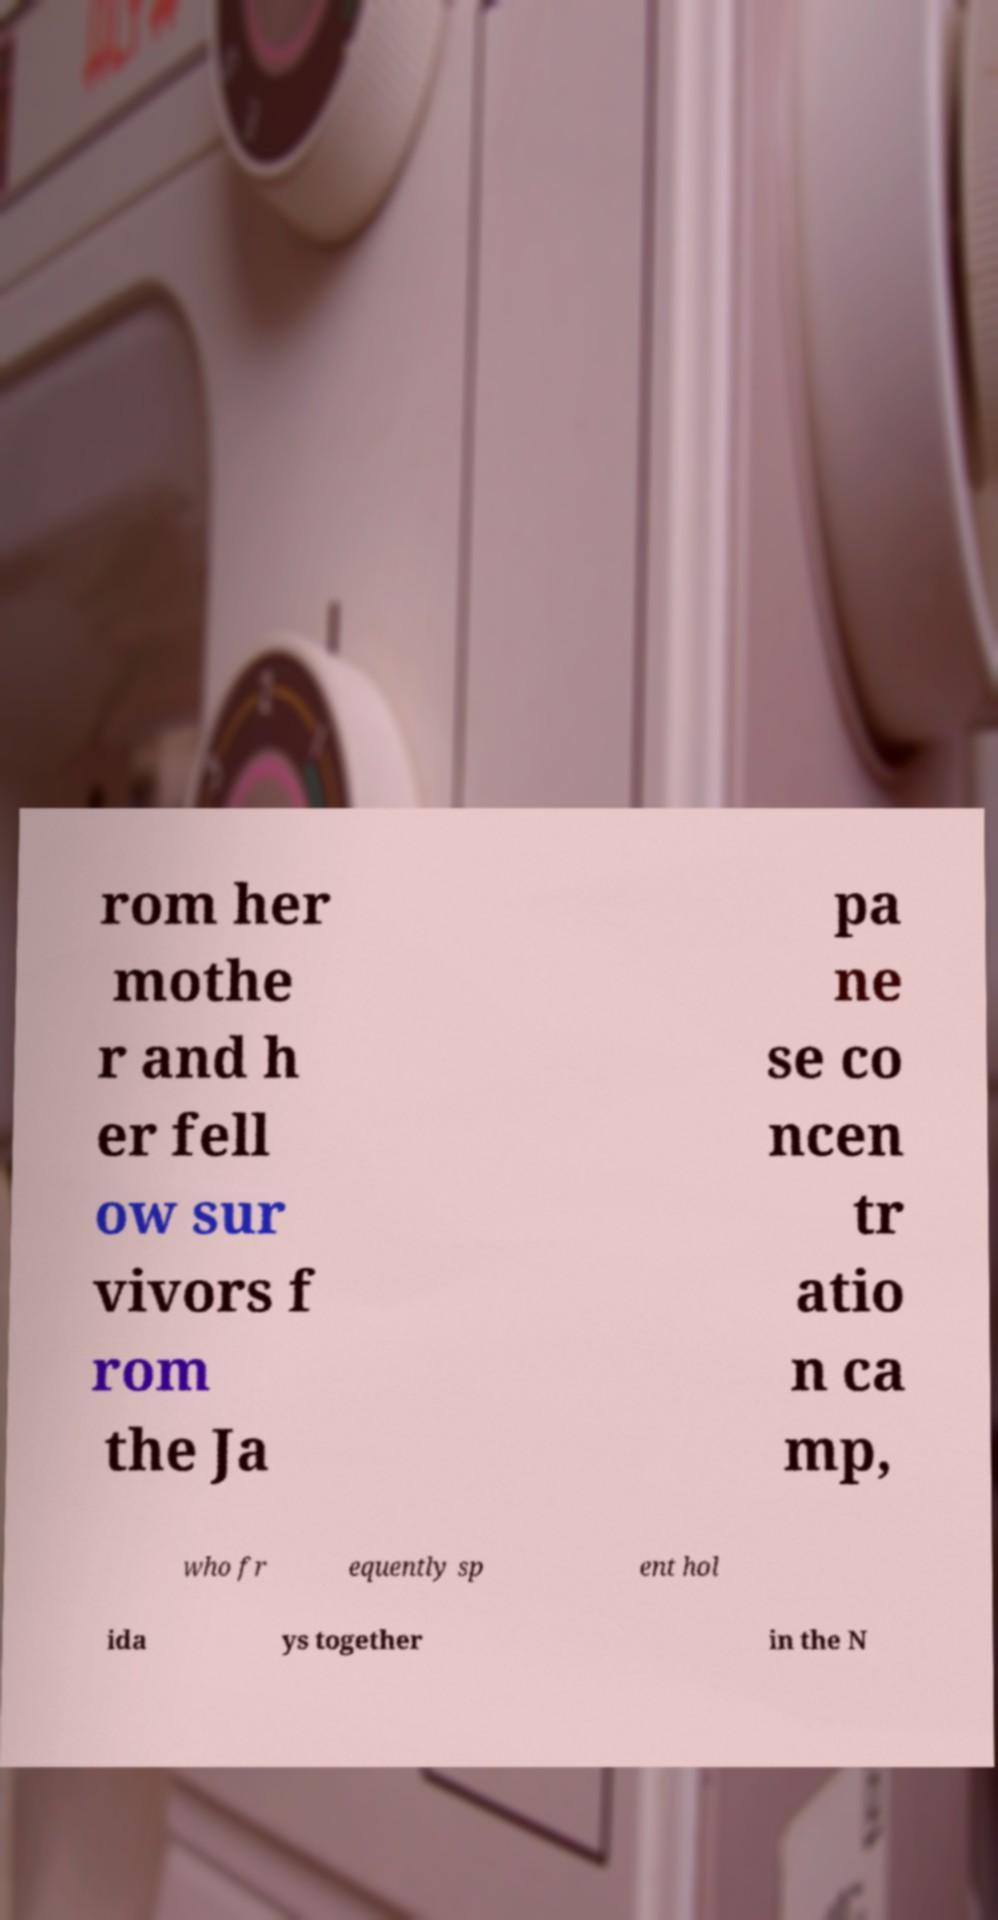Could you assist in decoding the text presented in this image and type it out clearly? rom her mothe r and h er fell ow sur vivors f rom the Ja pa ne se co ncen tr atio n ca mp, who fr equently sp ent hol ida ys together in the N 